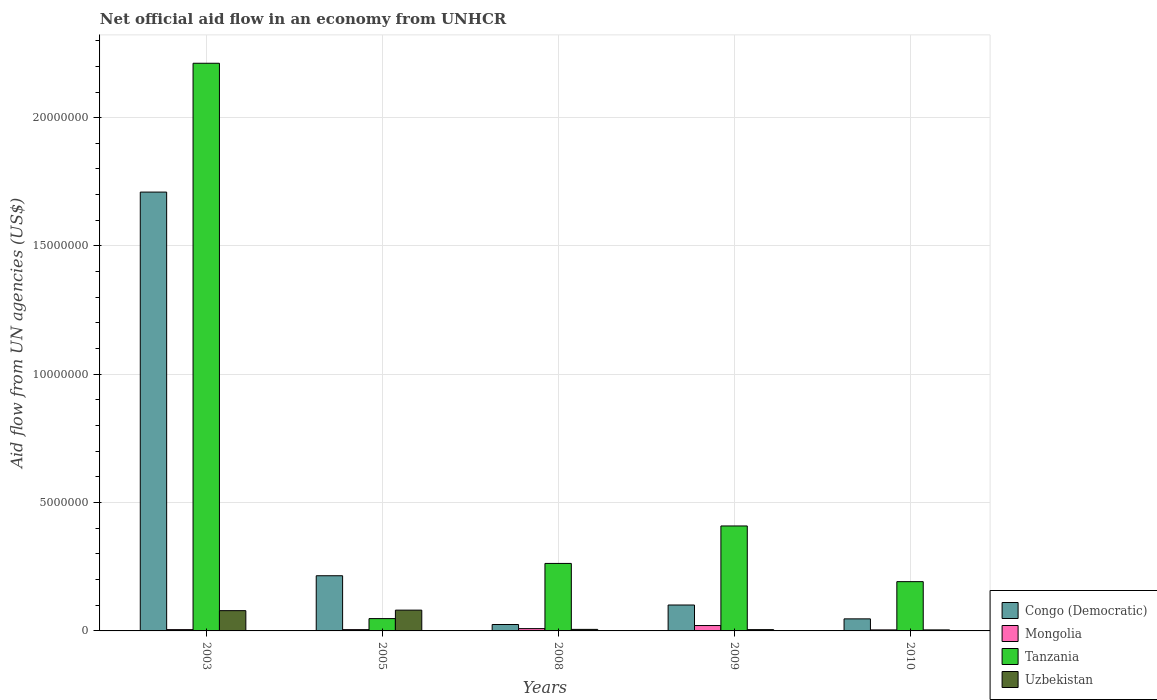How many different coloured bars are there?
Keep it short and to the point. 4. How many groups of bars are there?
Your response must be concise. 5. Are the number of bars per tick equal to the number of legend labels?
Keep it short and to the point. Yes. How many bars are there on the 1st tick from the right?
Your response must be concise. 4. What is the label of the 5th group of bars from the left?
Offer a very short reply. 2010. Across all years, what is the maximum net official aid flow in Uzbekistan?
Provide a short and direct response. 8.10e+05. What is the difference between the net official aid flow in Uzbekistan in 2003 and that in 2009?
Provide a succinct answer. 7.40e+05. What is the difference between the net official aid flow in Congo (Democratic) in 2003 and the net official aid flow in Tanzania in 2009?
Offer a very short reply. 1.30e+07. What is the average net official aid flow in Mongolia per year?
Make the answer very short. 8.80e+04. In the year 2005, what is the difference between the net official aid flow in Tanzania and net official aid flow in Mongolia?
Offer a very short reply. 4.30e+05. In how many years, is the net official aid flow in Congo (Democratic) greater than 17000000 US$?
Offer a very short reply. 1. What is the ratio of the net official aid flow in Uzbekistan in 2009 to that in 2010?
Offer a very short reply. 1.25. Is the net official aid flow in Uzbekistan in 2008 less than that in 2010?
Ensure brevity in your answer.  No. What is the difference between the highest and the second highest net official aid flow in Mongolia?
Keep it short and to the point. 1.20e+05. What is the difference between the highest and the lowest net official aid flow in Congo (Democratic)?
Keep it short and to the point. 1.68e+07. Is the sum of the net official aid flow in Tanzania in 2005 and 2009 greater than the maximum net official aid flow in Uzbekistan across all years?
Provide a short and direct response. Yes. Is it the case that in every year, the sum of the net official aid flow in Tanzania and net official aid flow in Uzbekistan is greater than the sum of net official aid flow in Mongolia and net official aid flow in Congo (Democratic)?
Offer a very short reply. Yes. What does the 4th bar from the left in 2009 represents?
Your response must be concise. Uzbekistan. What does the 3rd bar from the right in 2010 represents?
Offer a very short reply. Mongolia. Are all the bars in the graph horizontal?
Your response must be concise. No. How many years are there in the graph?
Give a very brief answer. 5. Are the values on the major ticks of Y-axis written in scientific E-notation?
Provide a short and direct response. No. Does the graph contain any zero values?
Keep it short and to the point. No. Does the graph contain grids?
Ensure brevity in your answer.  Yes. How are the legend labels stacked?
Offer a very short reply. Vertical. What is the title of the graph?
Offer a very short reply. Net official aid flow in an economy from UNHCR. What is the label or title of the X-axis?
Make the answer very short. Years. What is the label or title of the Y-axis?
Make the answer very short. Aid flow from UN agencies (US$). What is the Aid flow from UN agencies (US$) of Congo (Democratic) in 2003?
Provide a succinct answer. 1.71e+07. What is the Aid flow from UN agencies (US$) of Mongolia in 2003?
Ensure brevity in your answer.  5.00e+04. What is the Aid flow from UN agencies (US$) of Tanzania in 2003?
Make the answer very short. 2.21e+07. What is the Aid flow from UN agencies (US$) of Uzbekistan in 2003?
Provide a short and direct response. 7.90e+05. What is the Aid flow from UN agencies (US$) of Congo (Democratic) in 2005?
Your answer should be compact. 2.15e+06. What is the Aid flow from UN agencies (US$) of Uzbekistan in 2005?
Your answer should be compact. 8.10e+05. What is the Aid flow from UN agencies (US$) in Congo (Democratic) in 2008?
Provide a short and direct response. 2.50e+05. What is the Aid flow from UN agencies (US$) in Tanzania in 2008?
Offer a very short reply. 2.63e+06. What is the Aid flow from UN agencies (US$) of Uzbekistan in 2008?
Your response must be concise. 6.00e+04. What is the Aid flow from UN agencies (US$) in Congo (Democratic) in 2009?
Provide a succinct answer. 1.01e+06. What is the Aid flow from UN agencies (US$) of Tanzania in 2009?
Your answer should be compact. 4.09e+06. What is the Aid flow from UN agencies (US$) in Uzbekistan in 2009?
Your response must be concise. 5.00e+04. What is the Aid flow from UN agencies (US$) in Tanzania in 2010?
Make the answer very short. 1.92e+06. Across all years, what is the maximum Aid flow from UN agencies (US$) of Congo (Democratic)?
Your answer should be very brief. 1.71e+07. Across all years, what is the maximum Aid flow from UN agencies (US$) in Tanzania?
Provide a short and direct response. 2.21e+07. Across all years, what is the maximum Aid flow from UN agencies (US$) of Uzbekistan?
Provide a short and direct response. 8.10e+05. Across all years, what is the minimum Aid flow from UN agencies (US$) in Congo (Democratic)?
Your answer should be very brief. 2.50e+05. What is the total Aid flow from UN agencies (US$) of Congo (Democratic) in the graph?
Provide a short and direct response. 2.10e+07. What is the total Aid flow from UN agencies (US$) of Tanzania in the graph?
Keep it short and to the point. 3.12e+07. What is the total Aid flow from UN agencies (US$) in Uzbekistan in the graph?
Provide a succinct answer. 1.75e+06. What is the difference between the Aid flow from UN agencies (US$) of Congo (Democratic) in 2003 and that in 2005?
Your response must be concise. 1.50e+07. What is the difference between the Aid flow from UN agencies (US$) of Tanzania in 2003 and that in 2005?
Offer a very short reply. 2.16e+07. What is the difference between the Aid flow from UN agencies (US$) of Uzbekistan in 2003 and that in 2005?
Your answer should be very brief. -2.00e+04. What is the difference between the Aid flow from UN agencies (US$) in Congo (Democratic) in 2003 and that in 2008?
Provide a short and direct response. 1.68e+07. What is the difference between the Aid flow from UN agencies (US$) of Tanzania in 2003 and that in 2008?
Ensure brevity in your answer.  1.95e+07. What is the difference between the Aid flow from UN agencies (US$) of Uzbekistan in 2003 and that in 2008?
Make the answer very short. 7.30e+05. What is the difference between the Aid flow from UN agencies (US$) in Congo (Democratic) in 2003 and that in 2009?
Offer a terse response. 1.61e+07. What is the difference between the Aid flow from UN agencies (US$) of Mongolia in 2003 and that in 2009?
Keep it short and to the point. -1.60e+05. What is the difference between the Aid flow from UN agencies (US$) of Tanzania in 2003 and that in 2009?
Provide a succinct answer. 1.80e+07. What is the difference between the Aid flow from UN agencies (US$) in Uzbekistan in 2003 and that in 2009?
Provide a short and direct response. 7.40e+05. What is the difference between the Aid flow from UN agencies (US$) of Congo (Democratic) in 2003 and that in 2010?
Offer a very short reply. 1.66e+07. What is the difference between the Aid flow from UN agencies (US$) of Tanzania in 2003 and that in 2010?
Ensure brevity in your answer.  2.02e+07. What is the difference between the Aid flow from UN agencies (US$) of Uzbekistan in 2003 and that in 2010?
Offer a very short reply. 7.50e+05. What is the difference between the Aid flow from UN agencies (US$) in Congo (Democratic) in 2005 and that in 2008?
Keep it short and to the point. 1.90e+06. What is the difference between the Aid flow from UN agencies (US$) of Tanzania in 2005 and that in 2008?
Offer a very short reply. -2.15e+06. What is the difference between the Aid flow from UN agencies (US$) of Uzbekistan in 2005 and that in 2008?
Provide a short and direct response. 7.50e+05. What is the difference between the Aid flow from UN agencies (US$) in Congo (Democratic) in 2005 and that in 2009?
Provide a short and direct response. 1.14e+06. What is the difference between the Aid flow from UN agencies (US$) in Mongolia in 2005 and that in 2009?
Keep it short and to the point. -1.60e+05. What is the difference between the Aid flow from UN agencies (US$) of Tanzania in 2005 and that in 2009?
Your answer should be compact. -3.61e+06. What is the difference between the Aid flow from UN agencies (US$) in Uzbekistan in 2005 and that in 2009?
Your answer should be very brief. 7.60e+05. What is the difference between the Aid flow from UN agencies (US$) of Congo (Democratic) in 2005 and that in 2010?
Your response must be concise. 1.68e+06. What is the difference between the Aid flow from UN agencies (US$) in Mongolia in 2005 and that in 2010?
Keep it short and to the point. 10000. What is the difference between the Aid flow from UN agencies (US$) of Tanzania in 2005 and that in 2010?
Your answer should be compact. -1.44e+06. What is the difference between the Aid flow from UN agencies (US$) in Uzbekistan in 2005 and that in 2010?
Provide a short and direct response. 7.70e+05. What is the difference between the Aid flow from UN agencies (US$) in Congo (Democratic) in 2008 and that in 2009?
Offer a terse response. -7.60e+05. What is the difference between the Aid flow from UN agencies (US$) in Mongolia in 2008 and that in 2009?
Offer a terse response. -1.20e+05. What is the difference between the Aid flow from UN agencies (US$) of Tanzania in 2008 and that in 2009?
Ensure brevity in your answer.  -1.46e+06. What is the difference between the Aid flow from UN agencies (US$) of Congo (Democratic) in 2008 and that in 2010?
Offer a very short reply. -2.20e+05. What is the difference between the Aid flow from UN agencies (US$) of Tanzania in 2008 and that in 2010?
Your answer should be compact. 7.10e+05. What is the difference between the Aid flow from UN agencies (US$) of Congo (Democratic) in 2009 and that in 2010?
Make the answer very short. 5.40e+05. What is the difference between the Aid flow from UN agencies (US$) in Mongolia in 2009 and that in 2010?
Keep it short and to the point. 1.70e+05. What is the difference between the Aid flow from UN agencies (US$) in Tanzania in 2009 and that in 2010?
Provide a short and direct response. 2.17e+06. What is the difference between the Aid flow from UN agencies (US$) of Congo (Democratic) in 2003 and the Aid flow from UN agencies (US$) of Mongolia in 2005?
Provide a succinct answer. 1.70e+07. What is the difference between the Aid flow from UN agencies (US$) of Congo (Democratic) in 2003 and the Aid flow from UN agencies (US$) of Tanzania in 2005?
Provide a short and direct response. 1.66e+07. What is the difference between the Aid flow from UN agencies (US$) in Congo (Democratic) in 2003 and the Aid flow from UN agencies (US$) in Uzbekistan in 2005?
Offer a terse response. 1.63e+07. What is the difference between the Aid flow from UN agencies (US$) of Mongolia in 2003 and the Aid flow from UN agencies (US$) of Tanzania in 2005?
Keep it short and to the point. -4.30e+05. What is the difference between the Aid flow from UN agencies (US$) in Mongolia in 2003 and the Aid flow from UN agencies (US$) in Uzbekistan in 2005?
Ensure brevity in your answer.  -7.60e+05. What is the difference between the Aid flow from UN agencies (US$) in Tanzania in 2003 and the Aid flow from UN agencies (US$) in Uzbekistan in 2005?
Ensure brevity in your answer.  2.13e+07. What is the difference between the Aid flow from UN agencies (US$) of Congo (Democratic) in 2003 and the Aid flow from UN agencies (US$) of Mongolia in 2008?
Provide a succinct answer. 1.70e+07. What is the difference between the Aid flow from UN agencies (US$) of Congo (Democratic) in 2003 and the Aid flow from UN agencies (US$) of Tanzania in 2008?
Give a very brief answer. 1.45e+07. What is the difference between the Aid flow from UN agencies (US$) in Congo (Democratic) in 2003 and the Aid flow from UN agencies (US$) in Uzbekistan in 2008?
Ensure brevity in your answer.  1.70e+07. What is the difference between the Aid flow from UN agencies (US$) in Mongolia in 2003 and the Aid flow from UN agencies (US$) in Tanzania in 2008?
Provide a short and direct response. -2.58e+06. What is the difference between the Aid flow from UN agencies (US$) of Mongolia in 2003 and the Aid flow from UN agencies (US$) of Uzbekistan in 2008?
Provide a succinct answer. -10000. What is the difference between the Aid flow from UN agencies (US$) in Tanzania in 2003 and the Aid flow from UN agencies (US$) in Uzbekistan in 2008?
Give a very brief answer. 2.21e+07. What is the difference between the Aid flow from UN agencies (US$) in Congo (Democratic) in 2003 and the Aid flow from UN agencies (US$) in Mongolia in 2009?
Your response must be concise. 1.69e+07. What is the difference between the Aid flow from UN agencies (US$) of Congo (Democratic) in 2003 and the Aid flow from UN agencies (US$) of Tanzania in 2009?
Ensure brevity in your answer.  1.30e+07. What is the difference between the Aid flow from UN agencies (US$) in Congo (Democratic) in 2003 and the Aid flow from UN agencies (US$) in Uzbekistan in 2009?
Provide a short and direct response. 1.70e+07. What is the difference between the Aid flow from UN agencies (US$) in Mongolia in 2003 and the Aid flow from UN agencies (US$) in Tanzania in 2009?
Offer a terse response. -4.04e+06. What is the difference between the Aid flow from UN agencies (US$) in Tanzania in 2003 and the Aid flow from UN agencies (US$) in Uzbekistan in 2009?
Your answer should be very brief. 2.21e+07. What is the difference between the Aid flow from UN agencies (US$) in Congo (Democratic) in 2003 and the Aid flow from UN agencies (US$) in Mongolia in 2010?
Make the answer very short. 1.71e+07. What is the difference between the Aid flow from UN agencies (US$) of Congo (Democratic) in 2003 and the Aid flow from UN agencies (US$) of Tanzania in 2010?
Make the answer very short. 1.52e+07. What is the difference between the Aid flow from UN agencies (US$) in Congo (Democratic) in 2003 and the Aid flow from UN agencies (US$) in Uzbekistan in 2010?
Give a very brief answer. 1.71e+07. What is the difference between the Aid flow from UN agencies (US$) of Mongolia in 2003 and the Aid flow from UN agencies (US$) of Tanzania in 2010?
Ensure brevity in your answer.  -1.87e+06. What is the difference between the Aid flow from UN agencies (US$) in Mongolia in 2003 and the Aid flow from UN agencies (US$) in Uzbekistan in 2010?
Give a very brief answer. 10000. What is the difference between the Aid flow from UN agencies (US$) in Tanzania in 2003 and the Aid flow from UN agencies (US$) in Uzbekistan in 2010?
Make the answer very short. 2.21e+07. What is the difference between the Aid flow from UN agencies (US$) in Congo (Democratic) in 2005 and the Aid flow from UN agencies (US$) in Mongolia in 2008?
Offer a terse response. 2.06e+06. What is the difference between the Aid flow from UN agencies (US$) in Congo (Democratic) in 2005 and the Aid flow from UN agencies (US$) in Tanzania in 2008?
Your response must be concise. -4.80e+05. What is the difference between the Aid flow from UN agencies (US$) in Congo (Democratic) in 2005 and the Aid flow from UN agencies (US$) in Uzbekistan in 2008?
Offer a very short reply. 2.09e+06. What is the difference between the Aid flow from UN agencies (US$) of Mongolia in 2005 and the Aid flow from UN agencies (US$) of Tanzania in 2008?
Your response must be concise. -2.58e+06. What is the difference between the Aid flow from UN agencies (US$) of Congo (Democratic) in 2005 and the Aid flow from UN agencies (US$) of Mongolia in 2009?
Your answer should be very brief. 1.94e+06. What is the difference between the Aid flow from UN agencies (US$) in Congo (Democratic) in 2005 and the Aid flow from UN agencies (US$) in Tanzania in 2009?
Your response must be concise. -1.94e+06. What is the difference between the Aid flow from UN agencies (US$) in Congo (Democratic) in 2005 and the Aid flow from UN agencies (US$) in Uzbekistan in 2009?
Your answer should be very brief. 2.10e+06. What is the difference between the Aid flow from UN agencies (US$) of Mongolia in 2005 and the Aid flow from UN agencies (US$) of Tanzania in 2009?
Your answer should be very brief. -4.04e+06. What is the difference between the Aid flow from UN agencies (US$) of Congo (Democratic) in 2005 and the Aid flow from UN agencies (US$) of Mongolia in 2010?
Keep it short and to the point. 2.11e+06. What is the difference between the Aid flow from UN agencies (US$) in Congo (Democratic) in 2005 and the Aid flow from UN agencies (US$) in Uzbekistan in 2010?
Ensure brevity in your answer.  2.11e+06. What is the difference between the Aid flow from UN agencies (US$) of Mongolia in 2005 and the Aid flow from UN agencies (US$) of Tanzania in 2010?
Provide a succinct answer. -1.87e+06. What is the difference between the Aid flow from UN agencies (US$) of Mongolia in 2005 and the Aid flow from UN agencies (US$) of Uzbekistan in 2010?
Make the answer very short. 10000. What is the difference between the Aid flow from UN agencies (US$) of Congo (Democratic) in 2008 and the Aid flow from UN agencies (US$) of Mongolia in 2009?
Make the answer very short. 4.00e+04. What is the difference between the Aid flow from UN agencies (US$) in Congo (Democratic) in 2008 and the Aid flow from UN agencies (US$) in Tanzania in 2009?
Offer a terse response. -3.84e+06. What is the difference between the Aid flow from UN agencies (US$) of Congo (Democratic) in 2008 and the Aid flow from UN agencies (US$) of Uzbekistan in 2009?
Ensure brevity in your answer.  2.00e+05. What is the difference between the Aid flow from UN agencies (US$) of Tanzania in 2008 and the Aid flow from UN agencies (US$) of Uzbekistan in 2009?
Your answer should be compact. 2.58e+06. What is the difference between the Aid flow from UN agencies (US$) in Congo (Democratic) in 2008 and the Aid flow from UN agencies (US$) in Mongolia in 2010?
Your response must be concise. 2.10e+05. What is the difference between the Aid flow from UN agencies (US$) in Congo (Democratic) in 2008 and the Aid flow from UN agencies (US$) in Tanzania in 2010?
Offer a terse response. -1.67e+06. What is the difference between the Aid flow from UN agencies (US$) in Mongolia in 2008 and the Aid flow from UN agencies (US$) in Tanzania in 2010?
Your answer should be compact. -1.83e+06. What is the difference between the Aid flow from UN agencies (US$) in Mongolia in 2008 and the Aid flow from UN agencies (US$) in Uzbekistan in 2010?
Ensure brevity in your answer.  5.00e+04. What is the difference between the Aid flow from UN agencies (US$) of Tanzania in 2008 and the Aid flow from UN agencies (US$) of Uzbekistan in 2010?
Keep it short and to the point. 2.59e+06. What is the difference between the Aid flow from UN agencies (US$) of Congo (Democratic) in 2009 and the Aid flow from UN agencies (US$) of Mongolia in 2010?
Offer a very short reply. 9.70e+05. What is the difference between the Aid flow from UN agencies (US$) of Congo (Democratic) in 2009 and the Aid flow from UN agencies (US$) of Tanzania in 2010?
Provide a succinct answer. -9.10e+05. What is the difference between the Aid flow from UN agencies (US$) in Congo (Democratic) in 2009 and the Aid flow from UN agencies (US$) in Uzbekistan in 2010?
Your answer should be very brief. 9.70e+05. What is the difference between the Aid flow from UN agencies (US$) of Mongolia in 2009 and the Aid flow from UN agencies (US$) of Tanzania in 2010?
Your response must be concise. -1.71e+06. What is the difference between the Aid flow from UN agencies (US$) of Mongolia in 2009 and the Aid flow from UN agencies (US$) of Uzbekistan in 2010?
Your answer should be very brief. 1.70e+05. What is the difference between the Aid flow from UN agencies (US$) in Tanzania in 2009 and the Aid flow from UN agencies (US$) in Uzbekistan in 2010?
Your answer should be compact. 4.05e+06. What is the average Aid flow from UN agencies (US$) in Congo (Democratic) per year?
Your answer should be very brief. 4.20e+06. What is the average Aid flow from UN agencies (US$) of Mongolia per year?
Keep it short and to the point. 8.80e+04. What is the average Aid flow from UN agencies (US$) in Tanzania per year?
Ensure brevity in your answer.  6.25e+06. What is the average Aid flow from UN agencies (US$) of Uzbekistan per year?
Make the answer very short. 3.50e+05. In the year 2003, what is the difference between the Aid flow from UN agencies (US$) in Congo (Democratic) and Aid flow from UN agencies (US$) in Mongolia?
Provide a short and direct response. 1.70e+07. In the year 2003, what is the difference between the Aid flow from UN agencies (US$) of Congo (Democratic) and Aid flow from UN agencies (US$) of Tanzania?
Provide a succinct answer. -5.02e+06. In the year 2003, what is the difference between the Aid flow from UN agencies (US$) of Congo (Democratic) and Aid flow from UN agencies (US$) of Uzbekistan?
Ensure brevity in your answer.  1.63e+07. In the year 2003, what is the difference between the Aid flow from UN agencies (US$) of Mongolia and Aid flow from UN agencies (US$) of Tanzania?
Offer a very short reply. -2.21e+07. In the year 2003, what is the difference between the Aid flow from UN agencies (US$) in Mongolia and Aid flow from UN agencies (US$) in Uzbekistan?
Your answer should be compact. -7.40e+05. In the year 2003, what is the difference between the Aid flow from UN agencies (US$) in Tanzania and Aid flow from UN agencies (US$) in Uzbekistan?
Provide a succinct answer. 2.13e+07. In the year 2005, what is the difference between the Aid flow from UN agencies (US$) of Congo (Democratic) and Aid flow from UN agencies (US$) of Mongolia?
Your answer should be very brief. 2.10e+06. In the year 2005, what is the difference between the Aid flow from UN agencies (US$) in Congo (Democratic) and Aid flow from UN agencies (US$) in Tanzania?
Your response must be concise. 1.67e+06. In the year 2005, what is the difference between the Aid flow from UN agencies (US$) in Congo (Democratic) and Aid flow from UN agencies (US$) in Uzbekistan?
Make the answer very short. 1.34e+06. In the year 2005, what is the difference between the Aid flow from UN agencies (US$) of Mongolia and Aid flow from UN agencies (US$) of Tanzania?
Make the answer very short. -4.30e+05. In the year 2005, what is the difference between the Aid flow from UN agencies (US$) in Mongolia and Aid flow from UN agencies (US$) in Uzbekistan?
Provide a succinct answer. -7.60e+05. In the year 2005, what is the difference between the Aid flow from UN agencies (US$) of Tanzania and Aid flow from UN agencies (US$) of Uzbekistan?
Make the answer very short. -3.30e+05. In the year 2008, what is the difference between the Aid flow from UN agencies (US$) in Congo (Democratic) and Aid flow from UN agencies (US$) in Tanzania?
Provide a succinct answer. -2.38e+06. In the year 2008, what is the difference between the Aid flow from UN agencies (US$) of Mongolia and Aid flow from UN agencies (US$) of Tanzania?
Give a very brief answer. -2.54e+06. In the year 2008, what is the difference between the Aid flow from UN agencies (US$) in Tanzania and Aid flow from UN agencies (US$) in Uzbekistan?
Your answer should be compact. 2.57e+06. In the year 2009, what is the difference between the Aid flow from UN agencies (US$) of Congo (Democratic) and Aid flow from UN agencies (US$) of Tanzania?
Your answer should be very brief. -3.08e+06. In the year 2009, what is the difference between the Aid flow from UN agencies (US$) in Congo (Democratic) and Aid flow from UN agencies (US$) in Uzbekistan?
Offer a very short reply. 9.60e+05. In the year 2009, what is the difference between the Aid flow from UN agencies (US$) in Mongolia and Aid flow from UN agencies (US$) in Tanzania?
Ensure brevity in your answer.  -3.88e+06. In the year 2009, what is the difference between the Aid flow from UN agencies (US$) of Tanzania and Aid flow from UN agencies (US$) of Uzbekistan?
Offer a terse response. 4.04e+06. In the year 2010, what is the difference between the Aid flow from UN agencies (US$) in Congo (Democratic) and Aid flow from UN agencies (US$) in Mongolia?
Offer a very short reply. 4.30e+05. In the year 2010, what is the difference between the Aid flow from UN agencies (US$) in Congo (Democratic) and Aid flow from UN agencies (US$) in Tanzania?
Your answer should be very brief. -1.45e+06. In the year 2010, what is the difference between the Aid flow from UN agencies (US$) of Mongolia and Aid flow from UN agencies (US$) of Tanzania?
Make the answer very short. -1.88e+06. In the year 2010, what is the difference between the Aid flow from UN agencies (US$) of Tanzania and Aid flow from UN agencies (US$) of Uzbekistan?
Your answer should be very brief. 1.88e+06. What is the ratio of the Aid flow from UN agencies (US$) in Congo (Democratic) in 2003 to that in 2005?
Your answer should be very brief. 7.95. What is the ratio of the Aid flow from UN agencies (US$) in Mongolia in 2003 to that in 2005?
Your answer should be very brief. 1. What is the ratio of the Aid flow from UN agencies (US$) of Tanzania in 2003 to that in 2005?
Ensure brevity in your answer.  46.08. What is the ratio of the Aid flow from UN agencies (US$) of Uzbekistan in 2003 to that in 2005?
Ensure brevity in your answer.  0.98. What is the ratio of the Aid flow from UN agencies (US$) of Congo (Democratic) in 2003 to that in 2008?
Your response must be concise. 68.4. What is the ratio of the Aid flow from UN agencies (US$) in Mongolia in 2003 to that in 2008?
Provide a succinct answer. 0.56. What is the ratio of the Aid flow from UN agencies (US$) in Tanzania in 2003 to that in 2008?
Your answer should be compact. 8.41. What is the ratio of the Aid flow from UN agencies (US$) of Uzbekistan in 2003 to that in 2008?
Ensure brevity in your answer.  13.17. What is the ratio of the Aid flow from UN agencies (US$) in Congo (Democratic) in 2003 to that in 2009?
Your answer should be compact. 16.93. What is the ratio of the Aid flow from UN agencies (US$) in Mongolia in 2003 to that in 2009?
Make the answer very short. 0.24. What is the ratio of the Aid flow from UN agencies (US$) of Tanzania in 2003 to that in 2009?
Ensure brevity in your answer.  5.41. What is the ratio of the Aid flow from UN agencies (US$) of Uzbekistan in 2003 to that in 2009?
Your response must be concise. 15.8. What is the ratio of the Aid flow from UN agencies (US$) of Congo (Democratic) in 2003 to that in 2010?
Make the answer very short. 36.38. What is the ratio of the Aid flow from UN agencies (US$) in Tanzania in 2003 to that in 2010?
Your answer should be very brief. 11.52. What is the ratio of the Aid flow from UN agencies (US$) of Uzbekistan in 2003 to that in 2010?
Offer a terse response. 19.75. What is the ratio of the Aid flow from UN agencies (US$) of Congo (Democratic) in 2005 to that in 2008?
Your answer should be compact. 8.6. What is the ratio of the Aid flow from UN agencies (US$) of Mongolia in 2005 to that in 2008?
Keep it short and to the point. 0.56. What is the ratio of the Aid flow from UN agencies (US$) in Tanzania in 2005 to that in 2008?
Offer a very short reply. 0.18. What is the ratio of the Aid flow from UN agencies (US$) in Congo (Democratic) in 2005 to that in 2009?
Ensure brevity in your answer.  2.13. What is the ratio of the Aid flow from UN agencies (US$) of Mongolia in 2005 to that in 2009?
Make the answer very short. 0.24. What is the ratio of the Aid flow from UN agencies (US$) of Tanzania in 2005 to that in 2009?
Provide a short and direct response. 0.12. What is the ratio of the Aid flow from UN agencies (US$) in Congo (Democratic) in 2005 to that in 2010?
Ensure brevity in your answer.  4.57. What is the ratio of the Aid flow from UN agencies (US$) in Uzbekistan in 2005 to that in 2010?
Give a very brief answer. 20.25. What is the ratio of the Aid flow from UN agencies (US$) of Congo (Democratic) in 2008 to that in 2009?
Your response must be concise. 0.25. What is the ratio of the Aid flow from UN agencies (US$) in Mongolia in 2008 to that in 2009?
Offer a terse response. 0.43. What is the ratio of the Aid flow from UN agencies (US$) in Tanzania in 2008 to that in 2009?
Offer a very short reply. 0.64. What is the ratio of the Aid flow from UN agencies (US$) of Uzbekistan in 2008 to that in 2009?
Your response must be concise. 1.2. What is the ratio of the Aid flow from UN agencies (US$) of Congo (Democratic) in 2008 to that in 2010?
Give a very brief answer. 0.53. What is the ratio of the Aid flow from UN agencies (US$) in Mongolia in 2008 to that in 2010?
Keep it short and to the point. 2.25. What is the ratio of the Aid flow from UN agencies (US$) of Tanzania in 2008 to that in 2010?
Provide a succinct answer. 1.37. What is the ratio of the Aid flow from UN agencies (US$) of Uzbekistan in 2008 to that in 2010?
Your response must be concise. 1.5. What is the ratio of the Aid flow from UN agencies (US$) in Congo (Democratic) in 2009 to that in 2010?
Give a very brief answer. 2.15. What is the ratio of the Aid flow from UN agencies (US$) in Mongolia in 2009 to that in 2010?
Provide a short and direct response. 5.25. What is the ratio of the Aid flow from UN agencies (US$) of Tanzania in 2009 to that in 2010?
Make the answer very short. 2.13. What is the difference between the highest and the second highest Aid flow from UN agencies (US$) of Congo (Democratic)?
Your answer should be compact. 1.50e+07. What is the difference between the highest and the second highest Aid flow from UN agencies (US$) in Tanzania?
Give a very brief answer. 1.80e+07. What is the difference between the highest and the second highest Aid flow from UN agencies (US$) in Uzbekistan?
Your answer should be very brief. 2.00e+04. What is the difference between the highest and the lowest Aid flow from UN agencies (US$) of Congo (Democratic)?
Offer a terse response. 1.68e+07. What is the difference between the highest and the lowest Aid flow from UN agencies (US$) in Mongolia?
Give a very brief answer. 1.70e+05. What is the difference between the highest and the lowest Aid flow from UN agencies (US$) of Tanzania?
Make the answer very short. 2.16e+07. What is the difference between the highest and the lowest Aid flow from UN agencies (US$) of Uzbekistan?
Provide a succinct answer. 7.70e+05. 